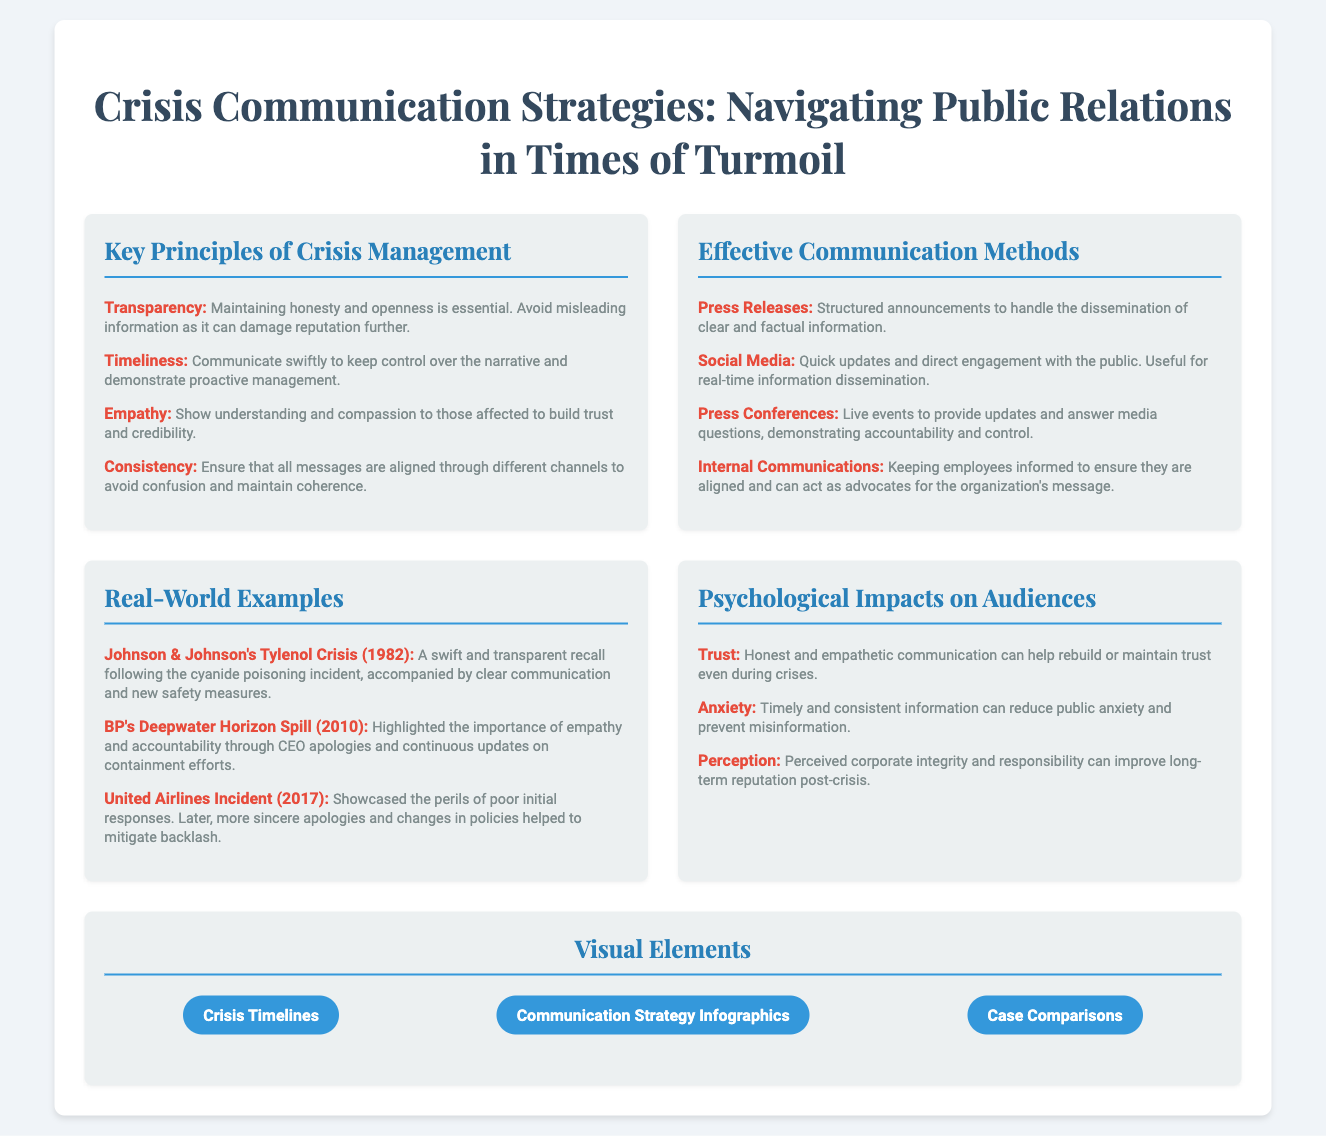what are the key principles of crisis management? The key principles are listed under the section titled "Key Principles of Crisis Management," and they include Transparency, Timeliness, Empathy, and Consistency.
Answer: Transparency, Timeliness, Empathy, Consistency what crisis management example involved a swift recall in 1982? The document mentions Johnson & Johnson's Tylenol Crisis as an example of a swift recall following a cyanide poisoning incident in 1982.
Answer: Johnson & Johnson's Tylenol Crisis which communication method allows quick updates and direct engagement? The section "Effective Communication Methods" states that Social Media is useful for quick updates and direct engagement with the public.
Answer: Social Media how does timely and consistent information impact public anxiety? The document explains that timely and consistent information can reduce public anxiety and prevent misinformation, which reflects its psychological impacts on audiences.
Answer: Reduce what are the visual elements included? The "Visual Elements" section mentions Crisis Timelines, Communication Strategy Infographics, and Case Comparisons as visual elements included in the presentation.
Answer: Crisis Timelines, Communication Strategy Infographics, Case Comparisons what lesson was learned from the United Airlines incident in 2017? The document discusses that the United Airlines incident highlighted the perils of poor initial responses, with more sincere apologies and changes in policies mitigating backlash.
Answer: Poor initial responses which principle emphasizes maintaining honesty and openness? The principle of Transparency emphasizes maintaining honesty and openness, as outlined in the "Key Principles of Crisis Management" section.
Answer: Transparency what psychological impact helps rebuild trust during crises? The document states that Honest and empathetic communication helps rebuild trust even during crises, indicating its psychological effect on audiences.
Answer: Trust 